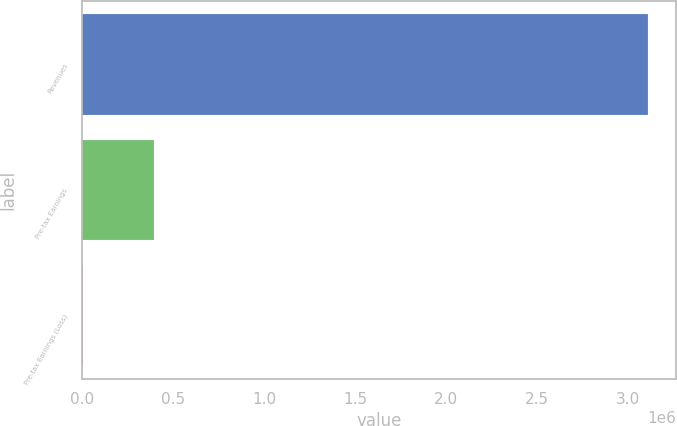<chart> <loc_0><loc_0><loc_500><loc_500><bar_chart><fcel>Revenues<fcel>Pre-tax Earnings<fcel>Pre-tax Earnings (Loss)<nl><fcel>3.10958e+06<fcel>392224<fcel>3652<nl></chart> 